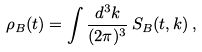<formula> <loc_0><loc_0><loc_500><loc_500>\rho _ { B } ( t ) = \int \frac { d ^ { 3 } k } { ( 2 \pi ) ^ { 3 } } \, S _ { B } ( t , k ) \, ,</formula> 